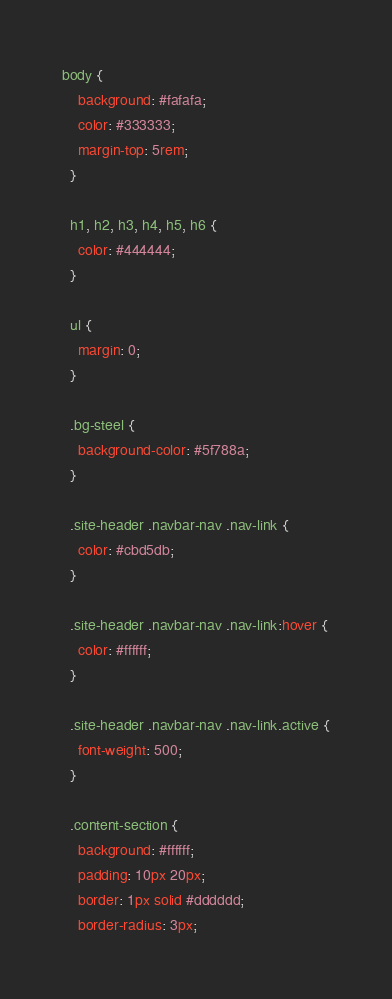<code> <loc_0><loc_0><loc_500><loc_500><_CSS_>body {
    background: #fafafa;
    color: #333333;
    margin-top: 5rem;
  }
  
  h1, h2, h3, h4, h5, h6 {
    color: #444444;
  }
  
  ul {
    margin: 0;
  }
  
  .bg-steel {
    background-color: #5f788a;
  }
  
  .site-header .navbar-nav .nav-link {
    color: #cbd5db;
  }
  
  .site-header .navbar-nav .nav-link:hover {
    color: #ffffff;
  }
  
  .site-header .navbar-nav .nav-link.active {
    font-weight: 500;
  }
  
  .content-section {
    background: #ffffff;
    padding: 10px 20px;
    border: 1px solid #dddddd;
    border-radius: 3px;</code> 